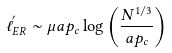<formula> <loc_0><loc_0><loc_500><loc_500>\ell ^ { ^ { \prime } } _ { E R } \sim \mu a p _ { c } \log \left ( \frac { N ^ { 1 / 3 } } { a p _ { c } } \right )</formula> 